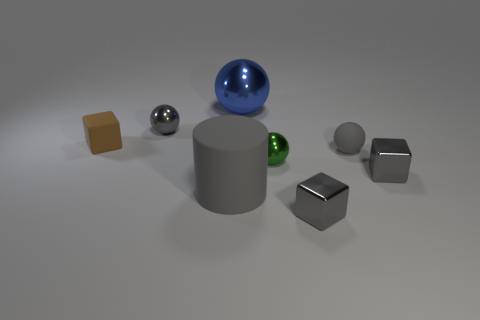There is a cube right of the gray ball that is in front of the small metallic sphere behind the brown block; what is it made of? The cube positioned to the right of the gray sphere and in front of the small metallic sphere, situated behind the brown block, appears to be made of a matte, possibly plastic material based on its lack of reflectivity and smooth surface texture. Unlike the metallic sphere, its surface does not reflect the environment sharply, suggesting it's not metallic. 